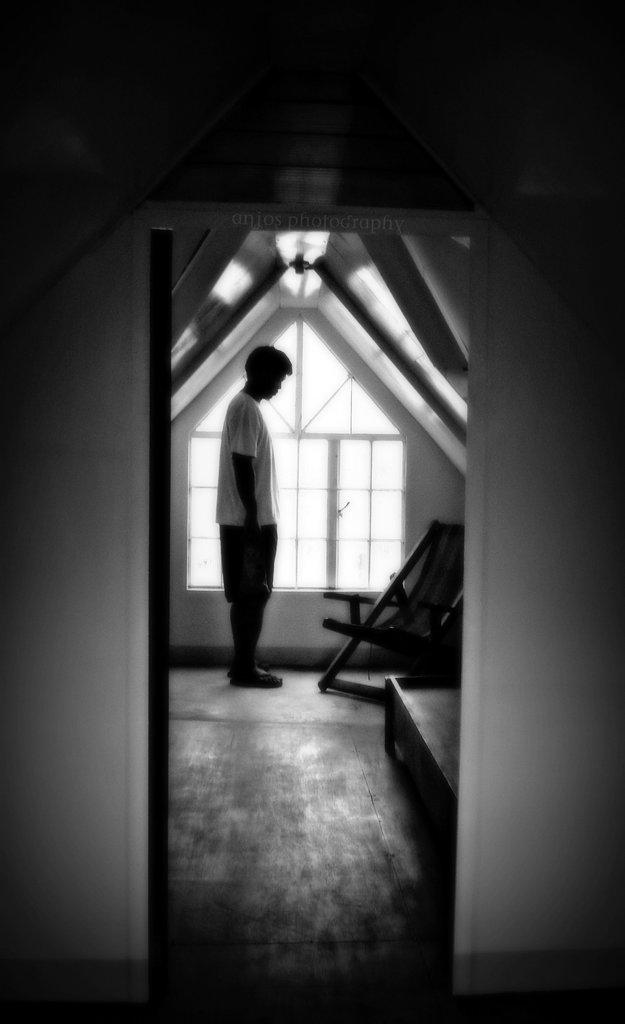Who is present in the room in the image? There is a man in the room. What is the man wearing in the image? The man is wearing a white t-shirt. What is the man's posture in the image? The man is standing. What piece of furniture is in front of the man? There is a chair in front of the man. What can be seen in the background of the room? There is a window in the background of the room. What level of expertise does the beginner ghost have in the image? There is no ghost present in the image, so it is not possible to determine the level of expertise of a beginner ghost. 